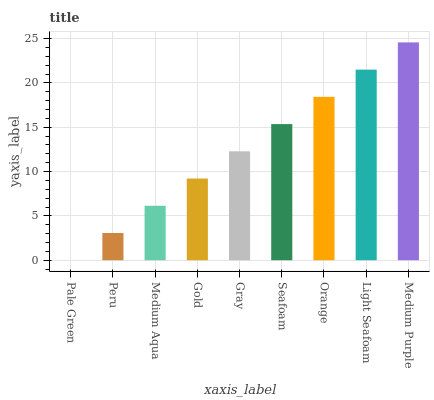Is Pale Green the minimum?
Answer yes or no. Yes. Is Medium Purple the maximum?
Answer yes or no. Yes. Is Peru the minimum?
Answer yes or no. No. Is Peru the maximum?
Answer yes or no. No. Is Peru greater than Pale Green?
Answer yes or no. Yes. Is Pale Green less than Peru?
Answer yes or no. Yes. Is Pale Green greater than Peru?
Answer yes or no. No. Is Peru less than Pale Green?
Answer yes or no. No. Is Gray the high median?
Answer yes or no. Yes. Is Gray the low median?
Answer yes or no. Yes. Is Gold the high median?
Answer yes or no. No. Is Peru the low median?
Answer yes or no. No. 